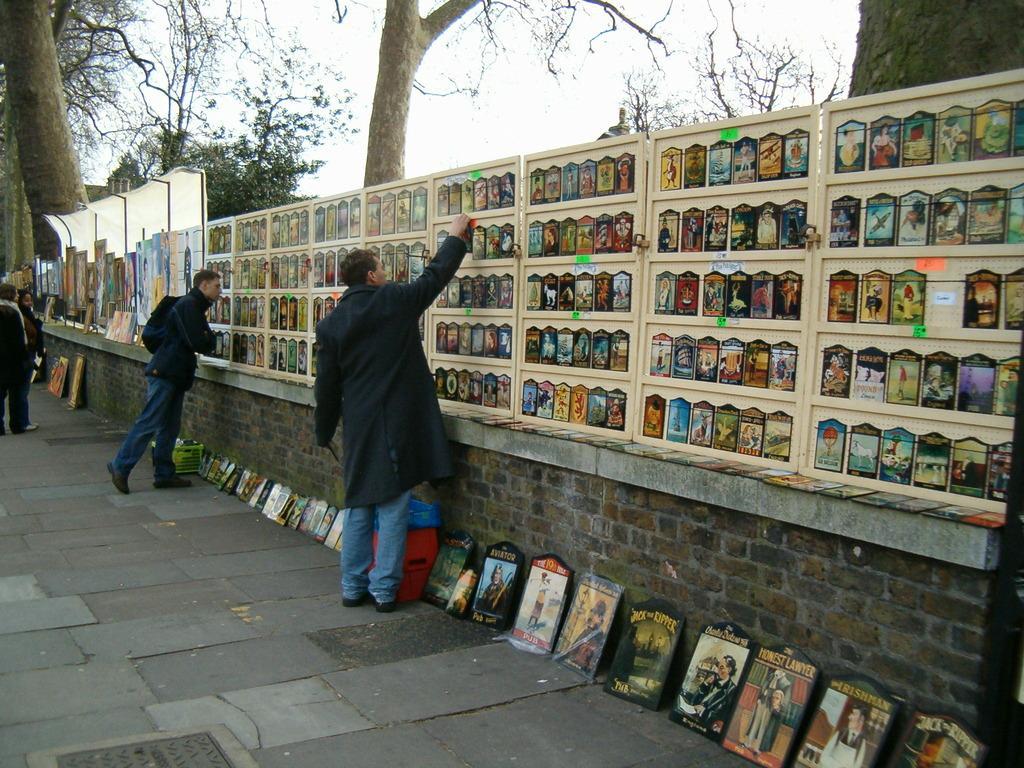Could you give a brief overview of what you see in this image? In the center of the image we can see boards, wall, some persons, trees, building, rods, cloth. At the bottom of the image there is a road. At the top of the image we can see the sky. 